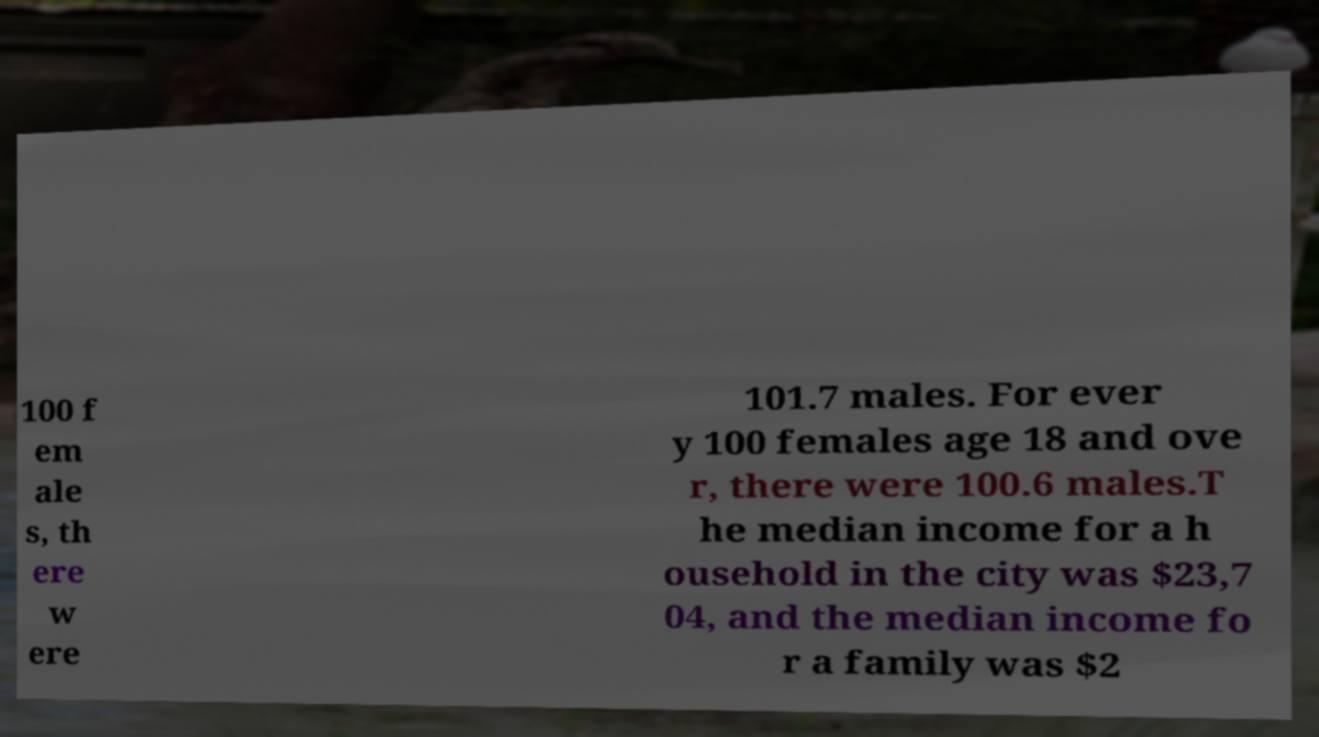Please read and relay the text visible in this image. What does it say? 100 f em ale s, th ere w ere 101.7 males. For ever y 100 females age 18 and ove r, there were 100.6 males.T he median income for a h ousehold in the city was $23,7 04, and the median income fo r a family was $2 